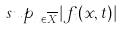<formula> <loc_0><loc_0><loc_500><loc_500>s u p _ { x \in \overline { X } } | f _ { t } ( x , t ) |</formula> 